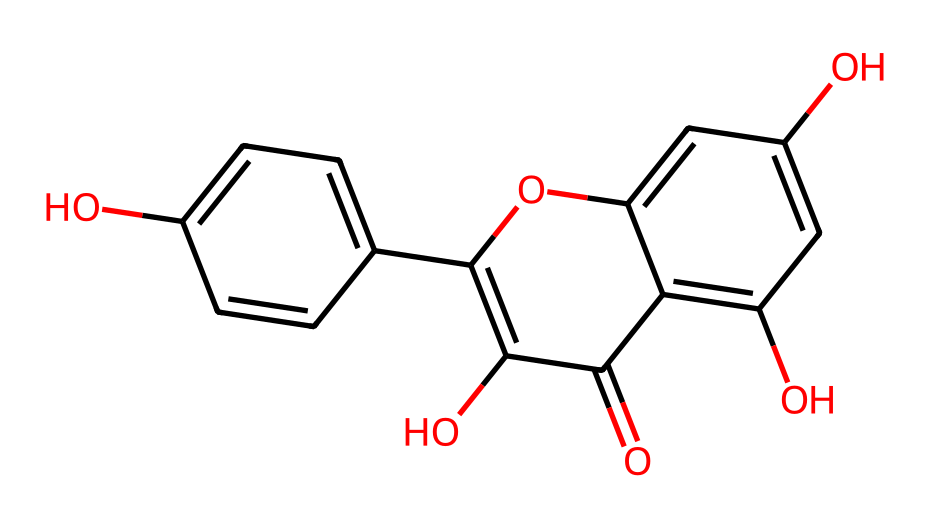What molecule does this SMILES represent? Analyzing the SMILES, we can see that it contains multiple phenolic groups and a carbonyl, indicative of a flavonoid or similar natural dye. The presence of hydroxyl (–OH) groups and carbon rings suggest it might be derived from a plant source typically used for dyeing.
Answer: flavonoid How many hydroxyl groups are present in this chemical? By carefully counting the –OH groups in the visual representation of the structure derived from the SMILES, there are four hydroxyl groups evidenced by the presence of the letters 'O' that are directly linked to carbon atoms.
Answer: four What is the main structural feature of this chemical that suggests its dyeing properties? The extended conjugated system of alternating double bonds within the ring structure indicates π-electron delocalization, which is characteristic of colored compounds, thereby suggesting strong dyeing properties.
Answer: conjugated system How many rings are present in this chemical structure? The chemical structure consists of two distinct ring systems based on the SMILES notation. Upon visualizing the molecule, we can identify these two cyclic structures.
Answer: two What type of natural sources could this dye likely be derived from? Given the structure and characteristics of the molecule, it is typical for such flavonoid compounds to be derived from plant sources such as fruits, flowers, or leaves, often used in traditional dyeing methods.
Answer: plants Is this dye likely to be water-soluble based on its structure? Considering the presence of multiple hydroxyl (-OH) groups, which increase polarity, it suggests that this chemical is likely to be water-soluble, which is essential for its application as a dye.
Answer: yes What color might this natural dye produce on fabrics? Due to the presence of the conjugated structure along with the specific arrangement of hydroxyl groups, such natural dyes often yield a range of colors including yellows to reds, depending on the mordant used in dyeing processes.
Answer: yellow to red 